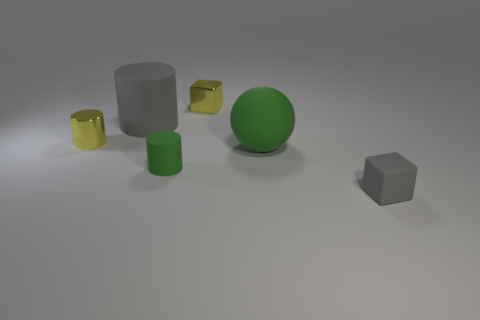Add 1 big balls. How many objects exist? 7 Subtract all blocks. How many objects are left? 4 Subtract 1 gray blocks. How many objects are left? 5 Subtract all large balls. Subtract all large purple balls. How many objects are left? 5 Add 4 yellow objects. How many yellow objects are left? 6 Add 1 red rubber spheres. How many red rubber spheres exist? 1 